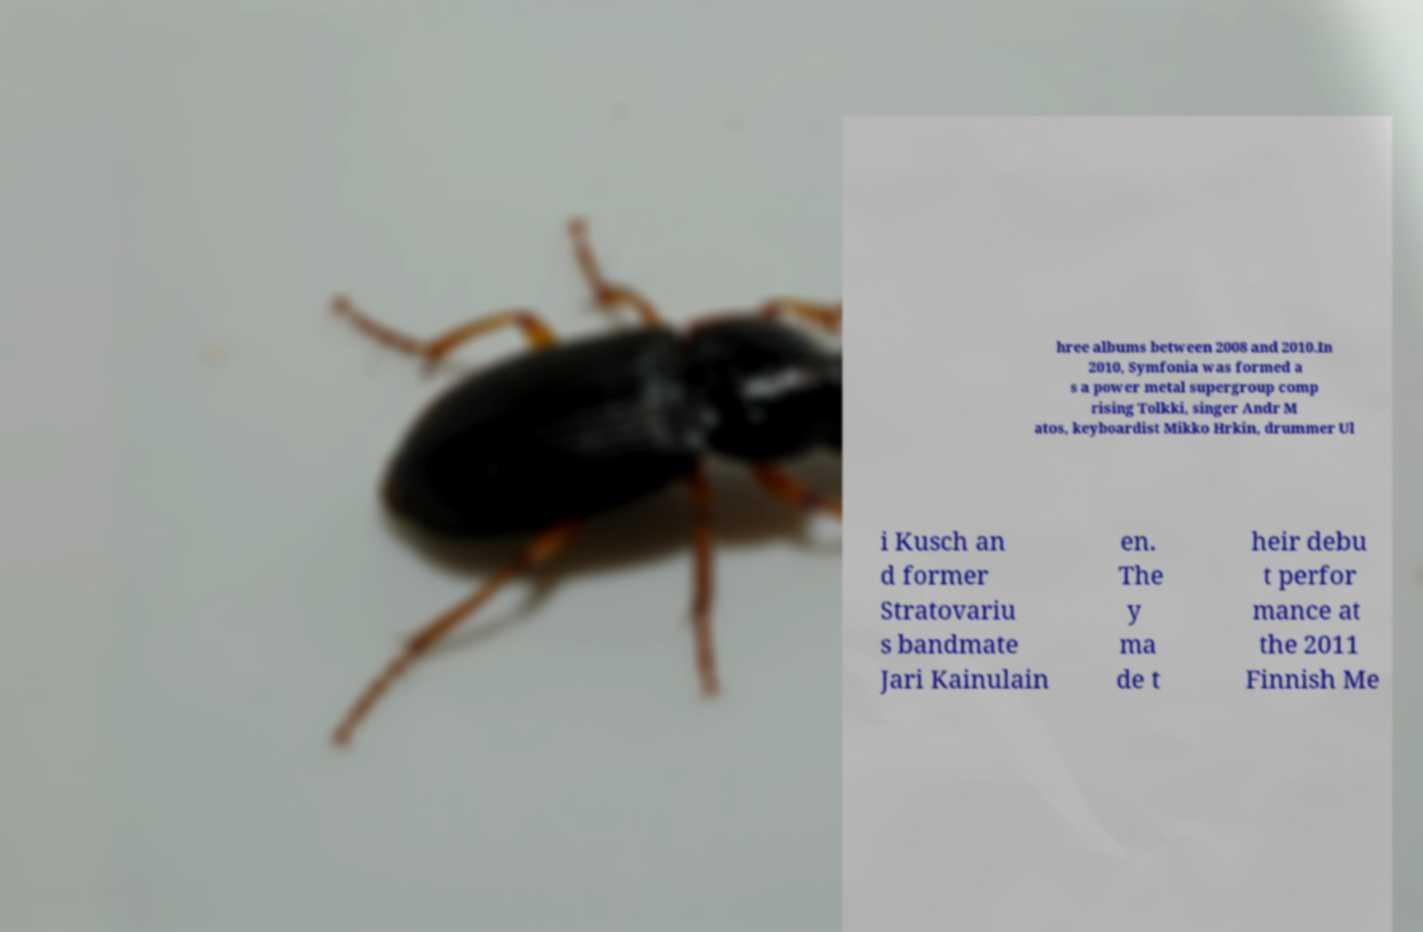There's text embedded in this image that I need extracted. Can you transcribe it verbatim? hree albums between 2008 and 2010.In 2010, Symfonia was formed a s a power metal supergroup comp rising Tolkki, singer Andr M atos, keyboardist Mikko Hrkin, drummer Ul i Kusch an d former Stratovariu s bandmate Jari Kainulain en. The y ma de t heir debu t perfor mance at the 2011 Finnish Me 